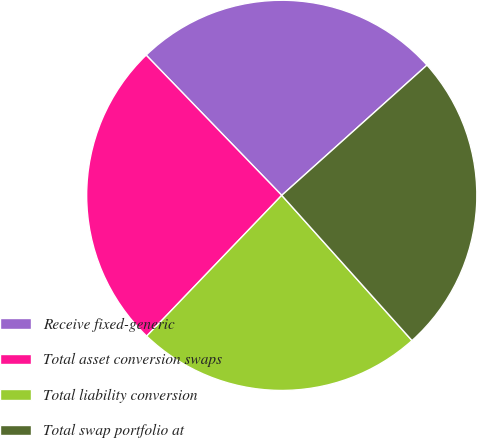Convert chart to OTSL. <chart><loc_0><loc_0><loc_500><loc_500><pie_chart><fcel>Receive fixed-generic<fcel>Total asset conversion swaps<fcel>Total liability conversion<fcel>Total swap portfolio at<nl><fcel>25.6%<fcel>25.6%<fcel>23.81%<fcel>25.0%<nl></chart> 